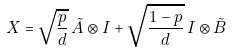Convert formula to latex. <formula><loc_0><loc_0><loc_500><loc_500>X = \sqrt { \frac { p } { d } } \, \tilde { A } \otimes I + \sqrt { \frac { 1 - p } { d } } \, I \otimes \tilde { B }</formula> 